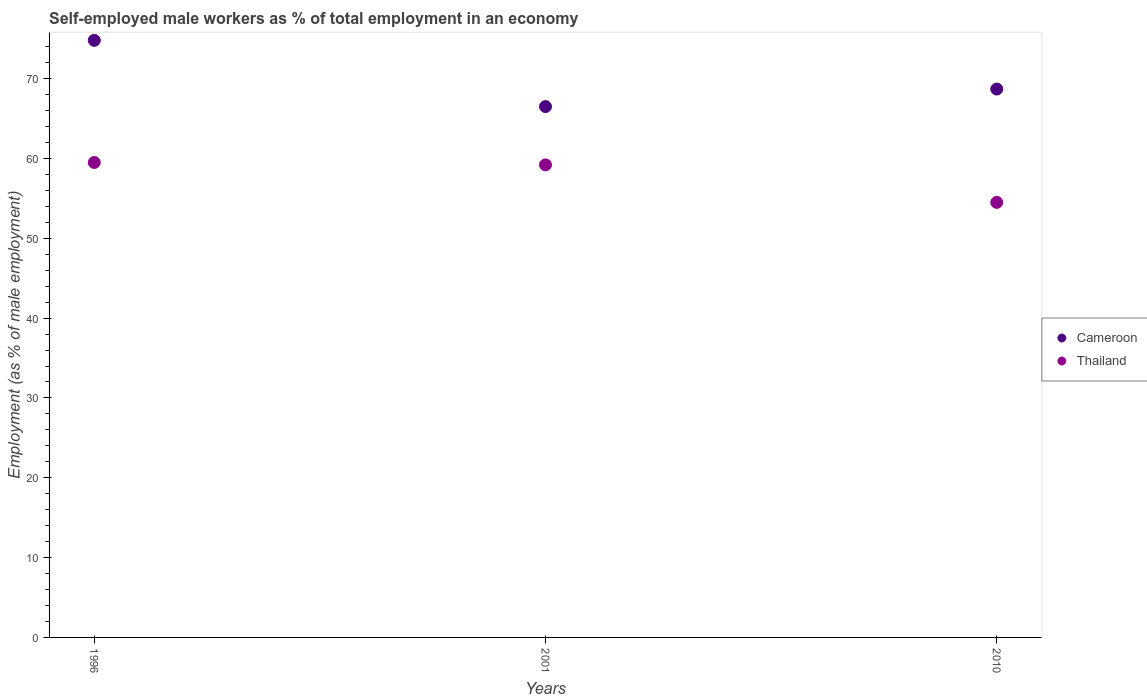Is the number of dotlines equal to the number of legend labels?
Give a very brief answer. Yes. What is the percentage of self-employed male workers in Cameroon in 1996?
Keep it short and to the point. 74.8. Across all years, what is the maximum percentage of self-employed male workers in Cameroon?
Your response must be concise. 74.8. Across all years, what is the minimum percentage of self-employed male workers in Thailand?
Your response must be concise. 54.5. What is the total percentage of self-employed male workers in Cameroon in the graph?
Your answer should be very brief. 210. What is the difference between the percentage of self-employed male workers in Cameroon in 1996 and that in 2001?
Provide a short and direct response. 8.3. In the year 2010, what is the difference between the percentage of self-employed male workers in Thailand and percentage of self-employed male workers in Cameroon?
Give a very brief answer. -14.2. In how many years, is the percentage of self-employed male workers in Thailand greater than 12 %?
Keep it short and to the point. 3. What is the ratio of the percentage of self-employed male workers in Thailand in 2001 to that in 2010?
Your response must be concise. 1.09. Is the percentage of self-employed male workers in Thailand in 2001 less than that in 2010?
Your response must be concise. No. What is the difference between the highest and the second highest percentage of self-employed male workers in Cameroon?
Keep it short and to the point. 6.1. What is the difference between the highest and the lowest percentage of self-employed male workers in Thailand?
Keep it short and to the point. 5. In how many years, is the percentage of self-employed male workers in Cameroon greater than the average percentage of self-employed male workers in Cameroon taken over all years?
Your response must be concise. 1. Is the sum of the percentage of self-employed male workers in Thailand in 1996 and 2001 greater than the maximum percentage of self-employed male workers in Cameroon across all years?
Make the answer very short. Yes. Does the percentage of self-employed male workers in Cameroon monotonically increase over the years?
Your answer should be compact. No. Is the percentage of self-employed male workers in Cameroon strictly less than the percentage of self-employed male workers in Thailand over the years?
Your answer should be very brief. No. How many dotlines are there?
Ensure brevity in your answer.  2. What is the difference between two consecutive major ticks on the Y-axis?
Provide a short and direct response. 10. Does the graph contain any zero values?
Your answer should be very brief. No. Does the graph contain grids?
Ensure brevity in your answer.  No. How are the legend labels stacked?
Provide a short and direct response. Vertical. What is the title of the graph?
Offer a very short reply. Self-employed male workers as % of total employment in an economy. What is the label or title of the Y-axis?
Provide a short and direct response. Employment (as % of male employment). What is the Employment (as % of male employment) of Cameroon in 1996?
Give a very brief answer. 74.8. What is the Employment (as % of male employment) in Thailand in 1996?
Provide a succinct answer. 59.5. What is the Employment (as % of male employment) in Cameroon in 2001?
Ensure brevity in your answer.  66.5. What is the Employment (as % of male employment) of Thailand in 2001?
Offer a very short reply. 59.2. What is the Employment (as % of male employment) in Cameroon in 2010?
Make the answer very short. 68.7. What is the Employment (as % of male employment) in Thailand in 2010?
Your answer should be compact. 54.5. Across all years, what is the maximum Employment (as % of male employment) in Cameroon?
Keep it short and to the point. 74.8. Across all years, what is the maximum Employment (as % of male employment) of Thailand?
Make the answer very short. 59.5. Across all years, what is the minimum Employment (as % of male employment) in Cameroon?
Your answer should be compact. 66.5. Across all years, what is the minimum Employment (as % of male employment) in Thailand?
Make the answer very short. 54.5. What is the total Employment (as % of male employment) of Cameroon in the graph?
Your answer should be very brief. 210. What is the total Employment (as % of male employment) in Thailand in the graph?
Offer a terse response. 173.2. What is the difference between the Employment (as % of male employment) in Cameroon in 1996 and that in 2001?
Your answer should be very brief. 8.3. What is the difference between the Employment (as % of male employment) of Cameroon in 1996 and that in 2010?
Your answer should be compact. 6.1. What is the difference between the Employment (as % of male employment) in Thailand in 2001 and that in 2010?
Your answer should be compact. 4.7. What is the difference between the Employment (as % of male employment) of Cameroon in 1996 and the Employment (as % of male employment) of Thailand in 2010?
Offer a terse response. 20.3. What is the average Employment (as % of male employment) in Cameroon per year?
Keep it short and to the point. 70. What is the average Employment (as % of male employment) of Thailand per year?
Provide a succinct answer. 57.73. In the year 2010, what is the difference between the Employment (as % of male employment) in Cameroon and Employment (as % of male employment) in Thailand?
Make the answer very short. 14.2. What is the ratio of the Employment (as % of male employment) of Cameroon in 1996 to that in 2001?
Offer a terse response. 1.12. What is the ratio of the Employment (as % of male employment) of Cameroon in 1996 to that in 2010?
Provide a succinct answer. 1.09. What is the ratio of the Employment (as % of male employment) of Thailand in 1996 to that in 2010?
Give a very brief answer. 1.09. What is the ratio of the Employment (as % of male employment) of Thailand in 2001 to that in 2010?
Offer a very short reply. 1.09. What is the difference between the highest and the second highest Employment (as % of male employment) in Cameroon?
Ensure brevity in your answer.  6.1. What is the difference between the highest and the lowest Employment (as % of male employment) of Cameroon?
Ensure brevity in your answer.  8.3. What is the difference between the highest and the lowest Employment (as % of male employment) in Thailand?
Your answer should be compact. 5. 